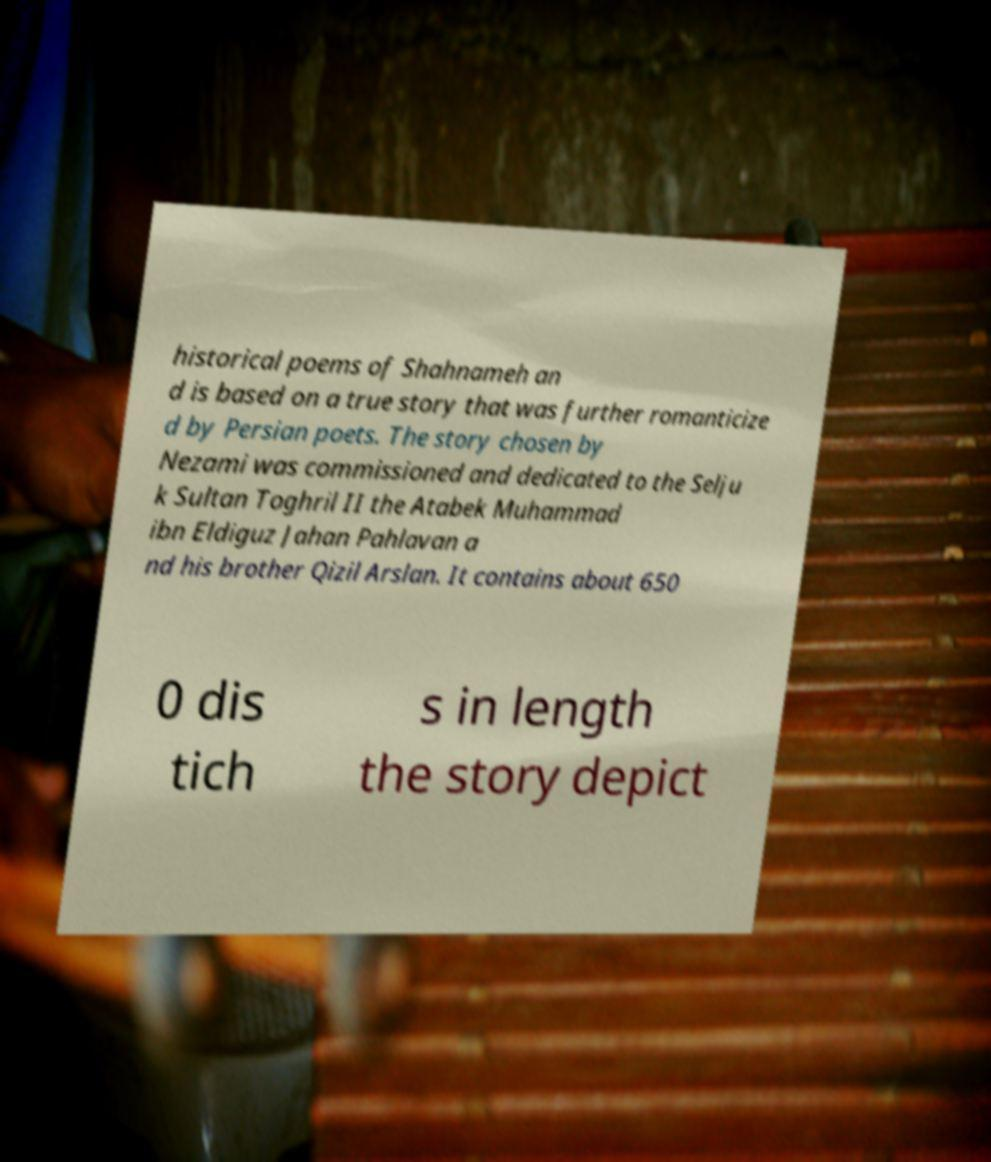Can you read and provide the text displayed in the image?This photo seems to have some interesting text. Can you extract and type it out for me? historical poems of Shahnameh an d is based on a true story that was further romanticize d by Persian poets. The story chosen by Nezami was commissioned and dedicated to the Selju k Sultan Toghril II the Atabek Muhammad ibn Eldiguz Jahan Pahlavan a nd his brother Qizil Arslan. It contains about 650 0 dis tich s in length the story depict 